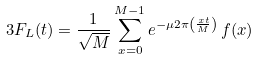Convert formula to latex. <formula><loc_0><loc_0><loc_500><loc_500>{ 3 } F _ { L } ( t ) = \frac { 1 } { \sqrt { M } } \sum _ { x = 0 } ^ { M - 1 } e ^ { - \mu 2 \pi \left ( \frac { x t } { M } \right ) } \, f ( x )</formula> 